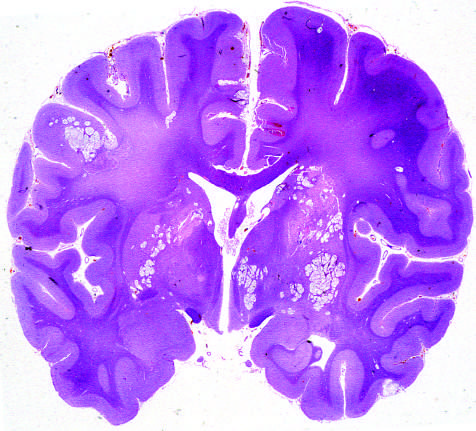how did whole-brain section show the numerous areas of tissue destruction associate?
Answer the question using a single word or phrase. With the spread of organisms in the perivascular spaces 